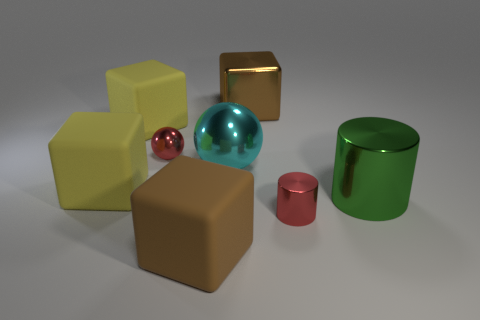Subtract 1 cubes. How many cubes are left? 3 Add 1 brown cubes. How many objects exist? 9 Subtract all spheres. How many objects are left? 6 Add 7 yellow shiny blocks. How many yellow shiny blocks exist? 7 Subtract 0 blue spheres. How many objects are left? 8 Subtract all large shiny cubes. Subtract all green cylinders. How many objects are left? 6 Add 1 cyan shiny spheres. How many cyan shiny spheres are left? 2 